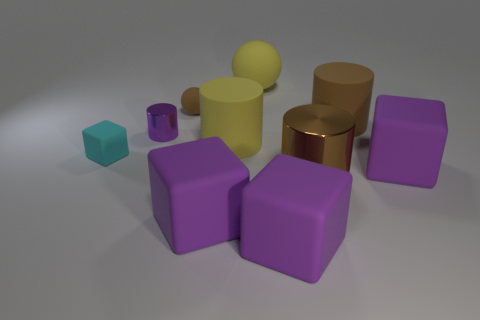Can you describe the lighting and shadows in the image? Certainly! The image is softly lit from above, casting gentle shadows beneath each object. The shadows are slightly elongated, indicating that the light source is not directly overhead but positioned at a slight angle. The overall brightness is uniform, suggesting an evenly diffused light source, which accentuates the shapes without creating harsh contrasts. 